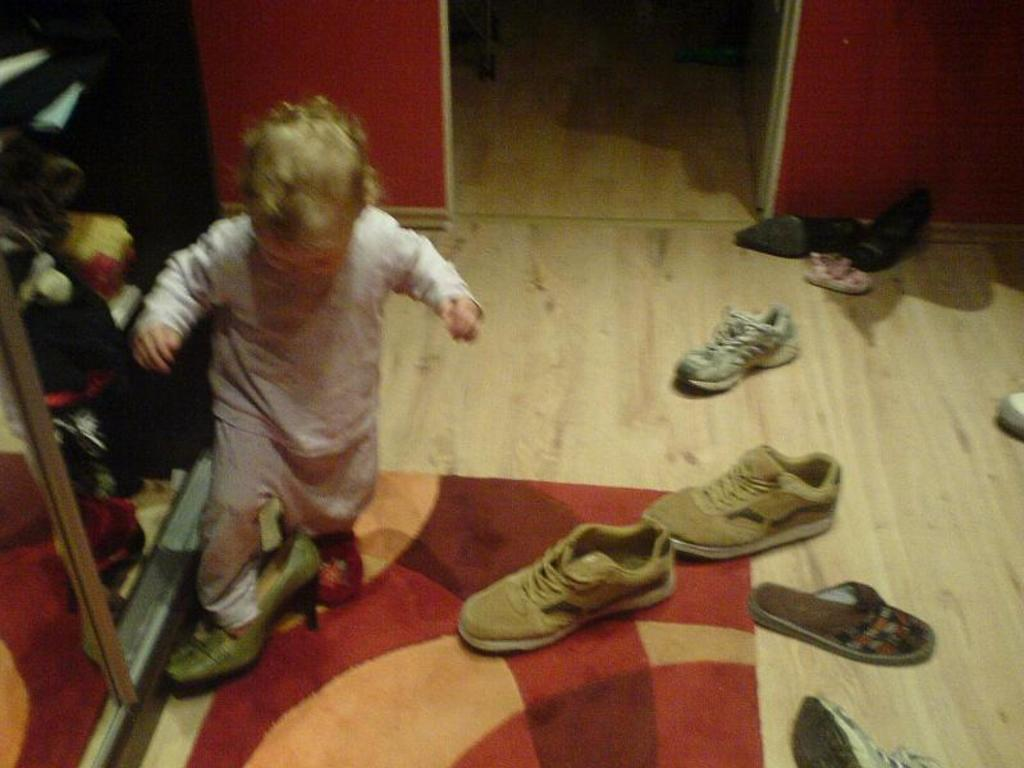Who is the main subject in the image? There is a small girl in the image. Where is the girl located in the image? The girl is on the left side of the image. What can be seen on the floor in the image? There are footwear and a rug on the floor in the image. What type of furniture is visible on the left side of the image? It appears there are cupboards on the left side of the image. How many pears are on the beds in the image? There are no pears or beds present in the image. What type of crow is sitting on the girl's shoulder in the image? There is no crow present in the image; it only features a small girl, footwear, a rug, and cupboards. 